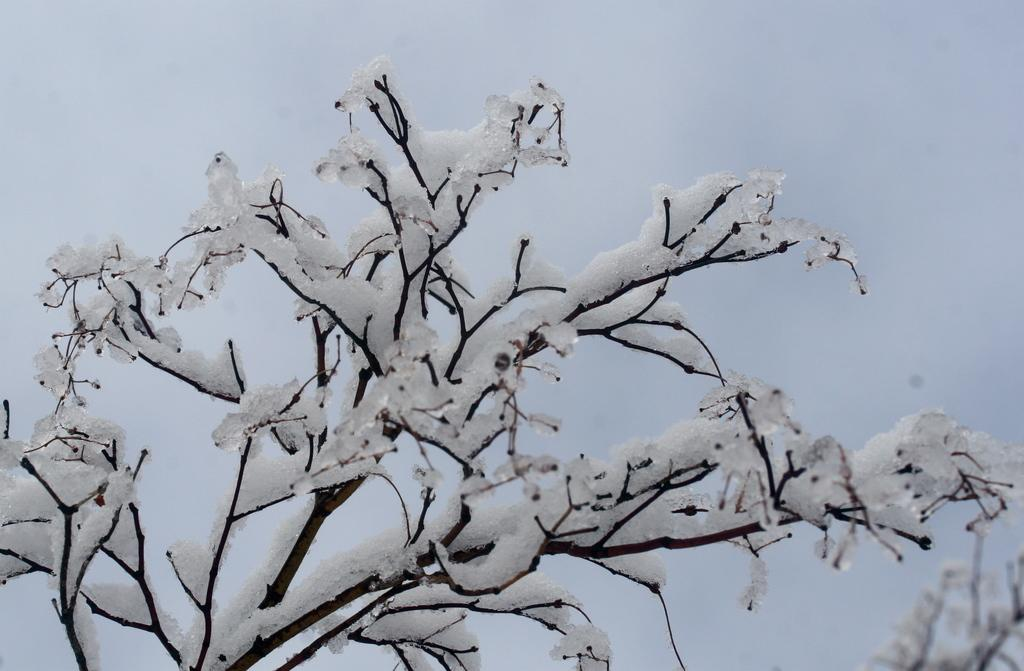What is the main subject of the image? There is a tree in the image. What is the condition of the tree? The tree is covered with snow. What can be seen in the background of the image? There is sky visible in the background of the image. What type of tub is visible in the image? There is no tub present in the image. Can you describe the elbow of the tree in the image? There is no specific mention of an elbow on the tree in the image, and trees do not have elbows like humans do. 